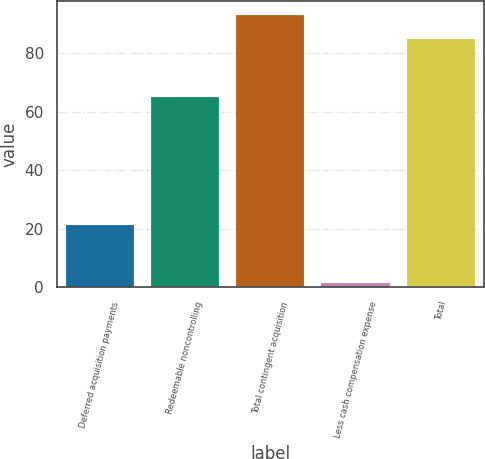Convert chart to OTSL. <chart><loc_0><loc_0><loc_500><loc_500><bar_chart><fcel>Deferred acquisition payments<fcel>Redeemable noncontrolling<fcel>Total contingent acquisition<fcel>Less cash compensation expense<fcel>Total<nl><fcel>21.3<fcel>65<fcel>93.17<fcel>1.6<fcel>84.7<nl></chart> 